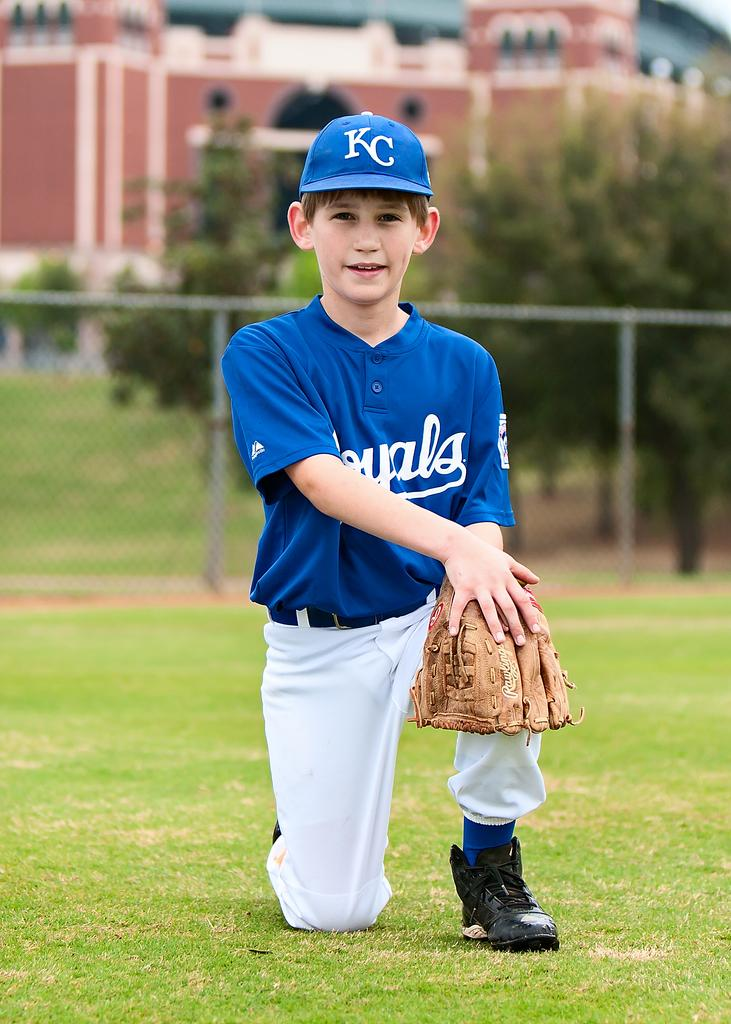<image>
Present a compact description of the photo's key features. A boy posing in a baseball uniform with the letters KC on his cap 